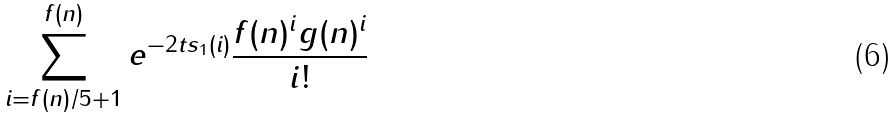<formula> <loc_0><loc_0><loc_500><loc_500>\sum _ { i = f ( n ) / 5 + 1 } ^ { f ( n ) } e ^ { - 2 t s _ { 1 } ( i ) } \frac { f ( n ) ^ { i } g ( n ) ^ { i } } { i ! }</formula> 